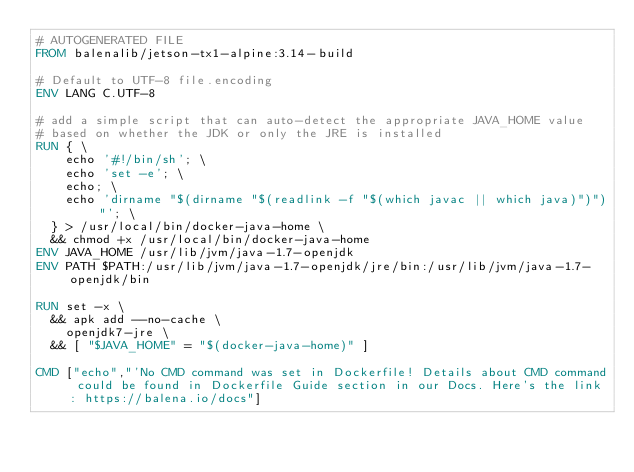Convert code to text. <code><loc_0><loc_0><loc_500><loc_500><_Dockerfile_># AUTOGENERATED FILE
FROM balenalib/jetson-tx1-alpine:3.14-build

# Default to UTF-8 file.encoding
ENV LANG C.UTF-8

# add a simple script that can auto-detect the appropriate JAVA_HOME value
# based on whether the JDK or only the JRE is installed
RUN { \
		echo '#!/bin/sh'; \
		echo 'set -e'; \
		echo; \
		echo 'dirname "$(dirname "$(readlink -f "$(which javac || which java)")")"'; \
	} > /usr/local/bin/docker-java-home \
	&& chmod +x /usr/local/bin/docker-java-home
ENV JAVA_HOME /usr/lib/jvm/java-1.7-openjdk
ENV PATH $PATH:/usr/lib/jvm/java-1.7-openjdk/jre/bin:/usr/lib/jvm/java-1.7-openjdk/bin

RUN set -x \
	&& apk add --no-cache \
		openjdk7-jre \
	&& [ "$JAVA_HOME" = "$(docker-java-home)" ]

CMD ["echo","'No CMD command was set in Dockerfile! Details about CMD command could be found in Dockerfile Guide section in our Docs. Here's the link: https://balena.io/docs"]
</code> 